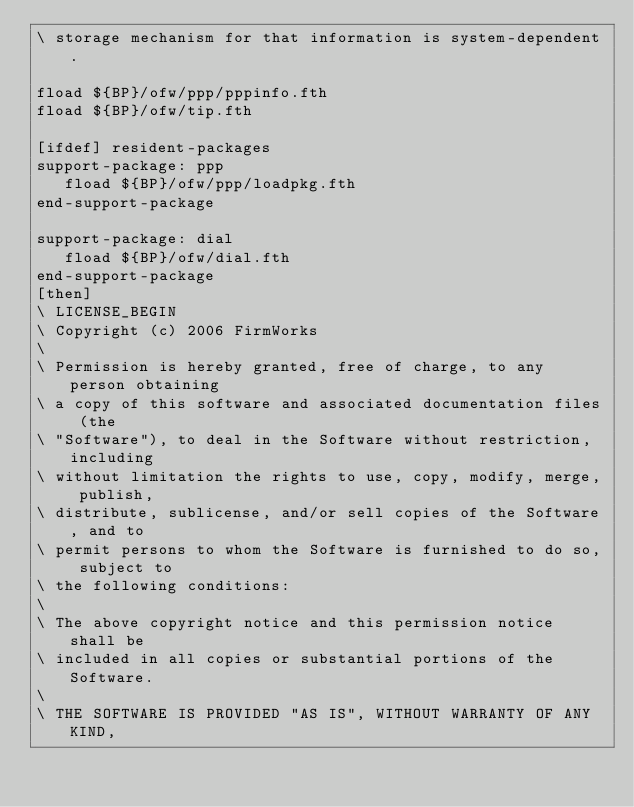<code> <loc_0><loc_0><loc_500><loc_500><_Forth_>\ storage mechanism for that information is system-dependent.

fload ${BP}/ofw/ppp/pppinfo.fth
fload ${BP}/ofw/tip.fth

[ifdef] resident-packages
support-package: ppp
   fload ${BP}/ofw/ppp/loadpkg.fth
end-support-package

support-package: dial
   fload ${BP}/ofw/dial.fth
end-support-package
[then]
\ LICENSE_BEGIN
\ Copyright (c) 2006 FirmWorks
\ 
\ Permission is hereby granted, free of charge, to any person obtaining
\ a copy of this software and associated documentation files (the
\ "Software"), to deal in the Software without restriction, including
\ without limitation the rights to use, copy, modify, merge, publish,
\ distribute, sublicense, and/or sell copies of the Software, and to
\ permit persons to whom the Software is furnished to do so, subject to
\ the following conditions:
\ 
\ The above copyright notice and this permission notice shall be
\ included in all copies or substantial portions of the Software.
\ 
\ THE SOFTWARE IS PROVIDED "AS IS", WITHOUT WARRANTY OF ANY KIND,</code> 